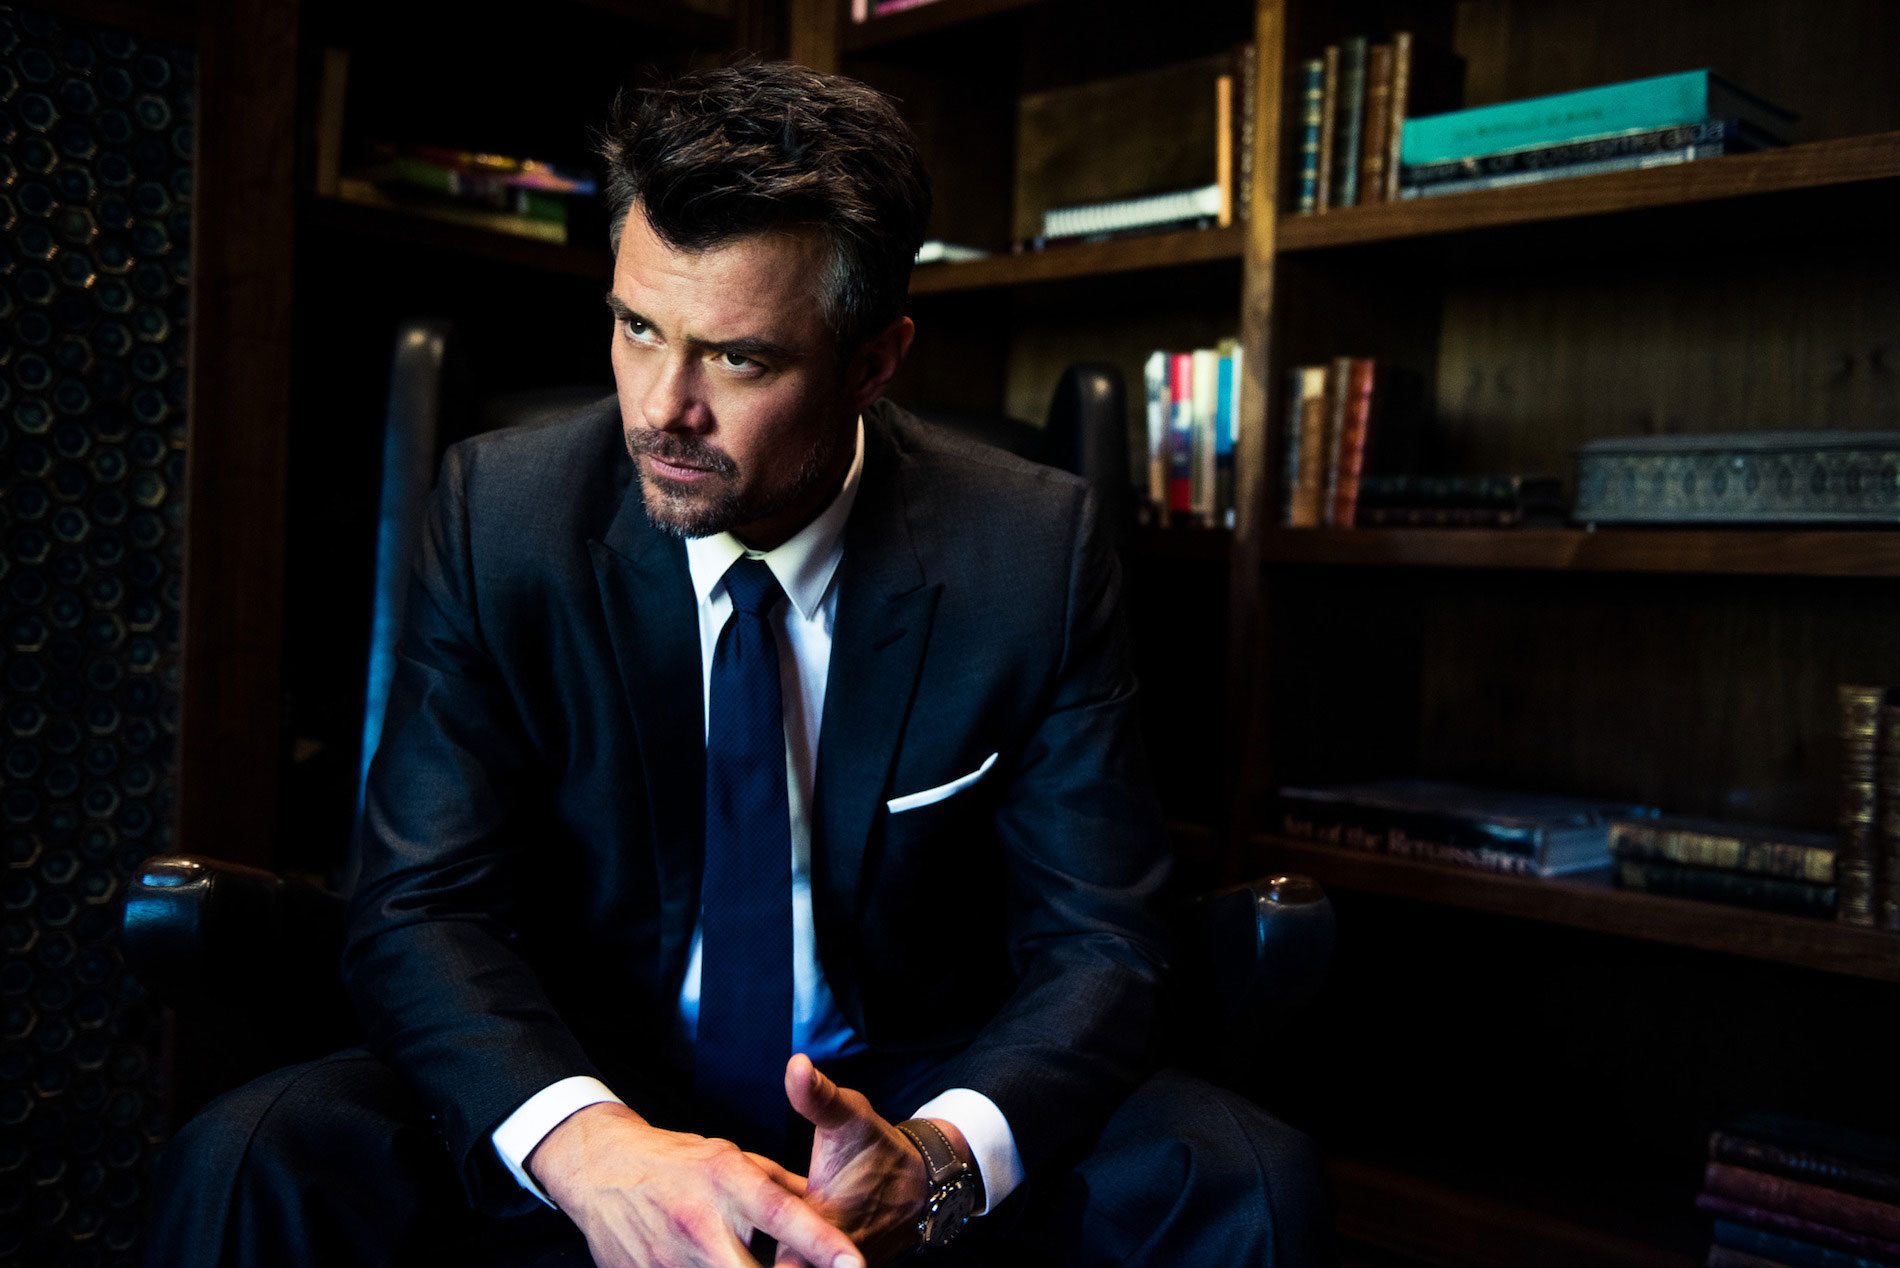Can you describe any specific books or objects on the shelf that might tell us more about the person's interests? From the visible details, there's a wide array of books that span different genres, suggesting diverse interests. Notable is a book that appears to be about Renaissance art and another that looks like a modern novel. These books indicate the individual's appreciation for both historical and contemporary culture. 